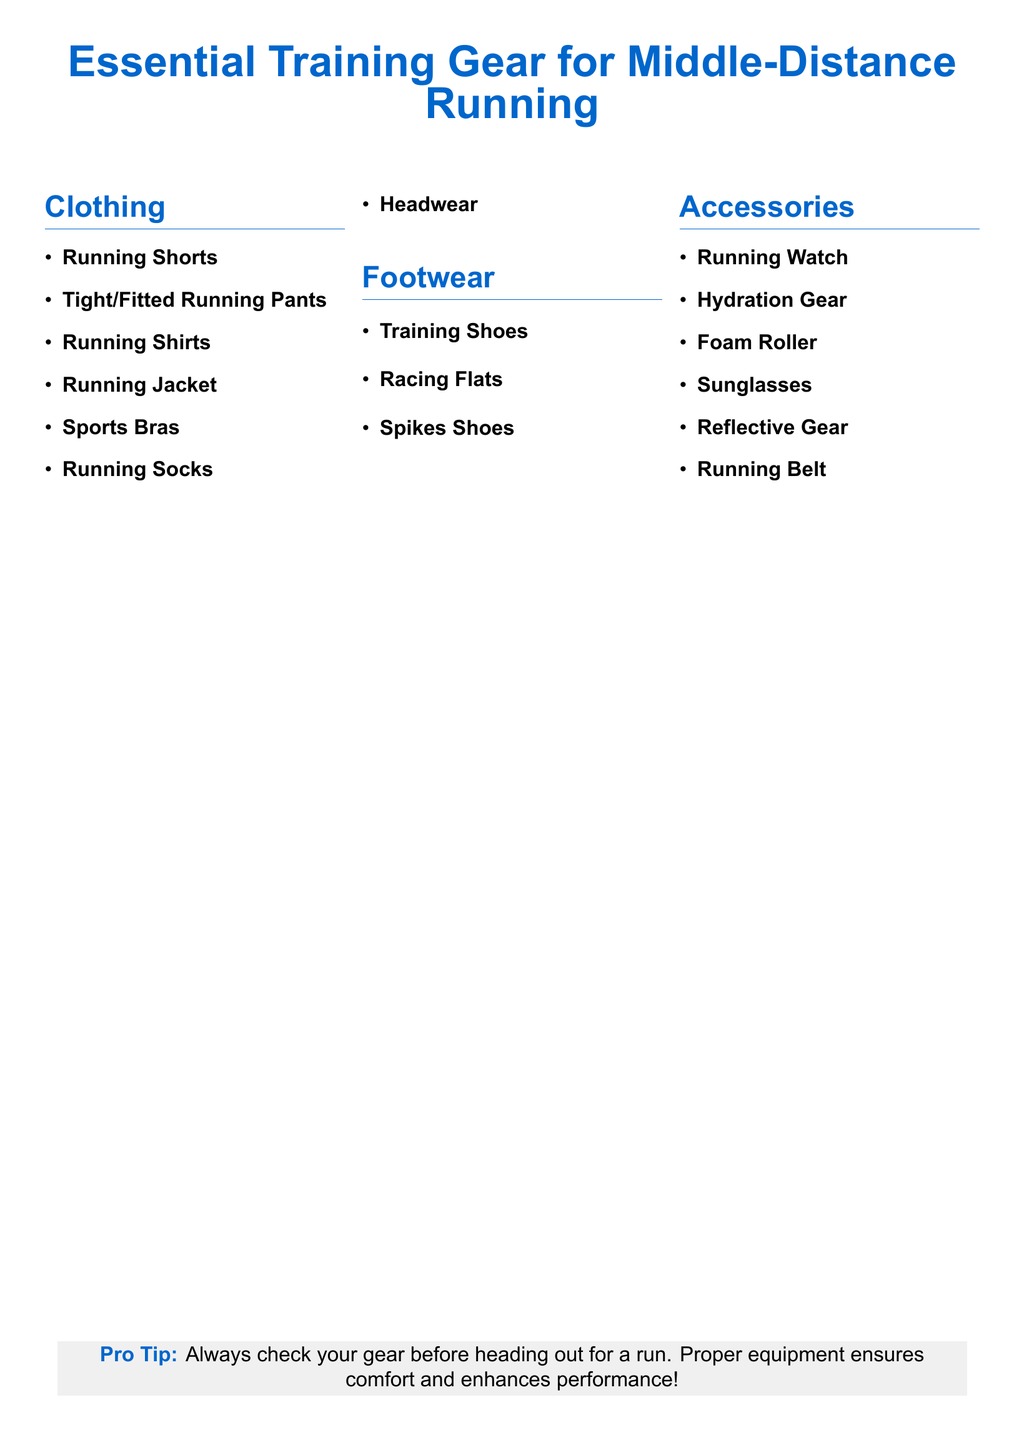what are the types of clothing listed? The document lists specific types of clothing essential for middle-distance running, such as running shorts and shirts.
Answer: Running Shorts, Tight/Fitted Running Pants, Running Shirts, Running Jacket, Sports Bras, Running Socks, Headwear how many pairs of footwear are mentioned? The document specifies three types of footwear essential for running.
Answer: 3 name one accessory from the list. The document highlights important accessories for training, including options like running watches and hydration gear.
Answer: Running Watch what is included in the clothing section? The clothing section contains multiple items important for middle-distance running training.
Answer: Running Shorts, Tight/Fitted Running Pants, Running Shirts, Running Jacket, Sports Bras, Running Socks, Headwear what is the purpose of a running belt? The running belt is included as an accessory essential for carrying items securely while running.
Answer: Carry items securely which category does the "Foam Roller" fall under? The document categorizes the foam roller as an important item in the accessories section for runners.
Answer: Accessories what color is used for the title? The title of the document is designed with a specific color to enhance its visibility and appeal.
Answer: runnerblue 